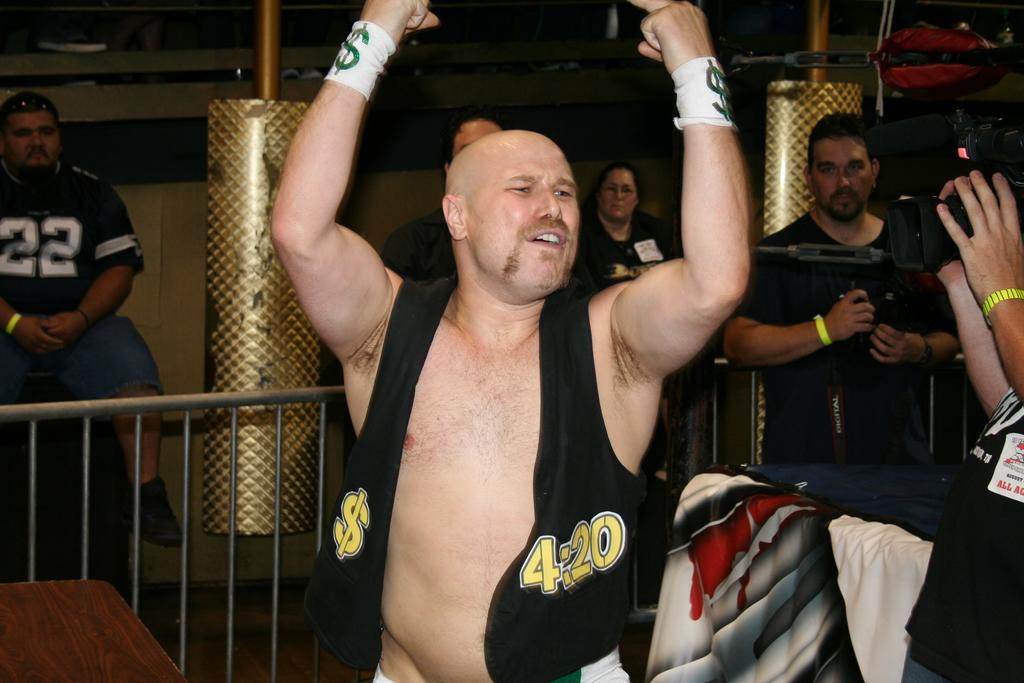<image>
Summarize the visual content of the image. The man wearing the vest has 4:20 on his black vest. 